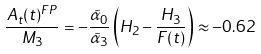<formula> <loc_0><loc_0><loc_500><loc_500>\frac { A _ { t } ( t ) ^ { F P } } { M _ { 3 } } = - \frac { \tilde { \alpha } _ { 0 } } { \tilde { \alpha } _ { 3 } } \left ( H _ { 2 } - \frac { H _ { 3 } } { F ( t ) } \right ) \approx - 0 . 6 2 \,</formula> 